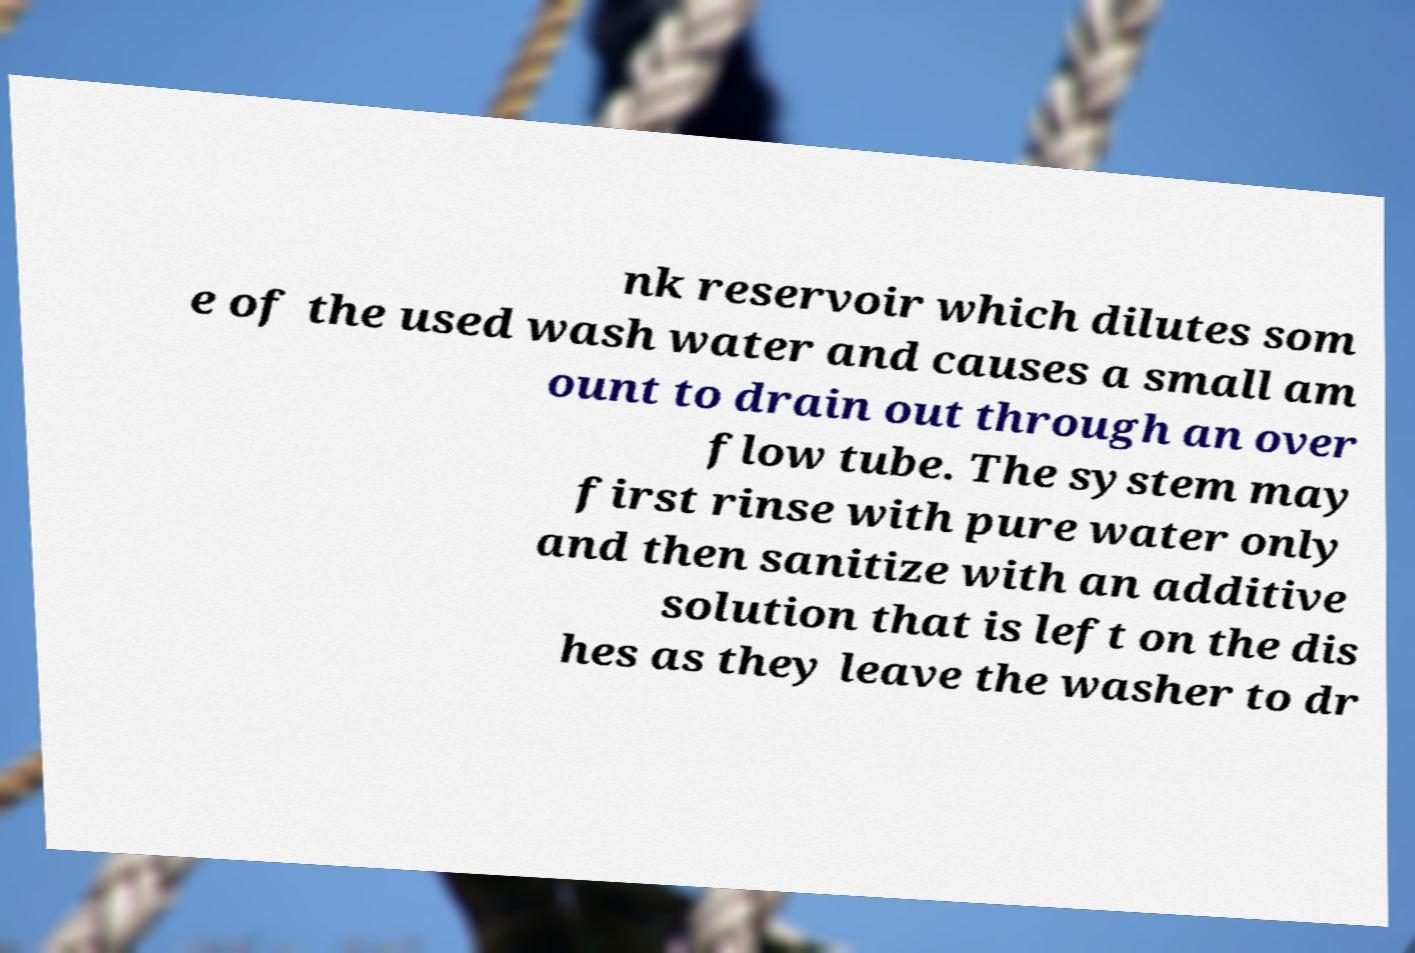Please identify and transcribe the text found in this image. nk reservoir which dilutes som e of the used wash water and causes a small am ount to drain out through an over flow tube. The system may first rinse with pure water only and then sanitize with an additive solution that is left on the dis hes as they leave the washer to dr 